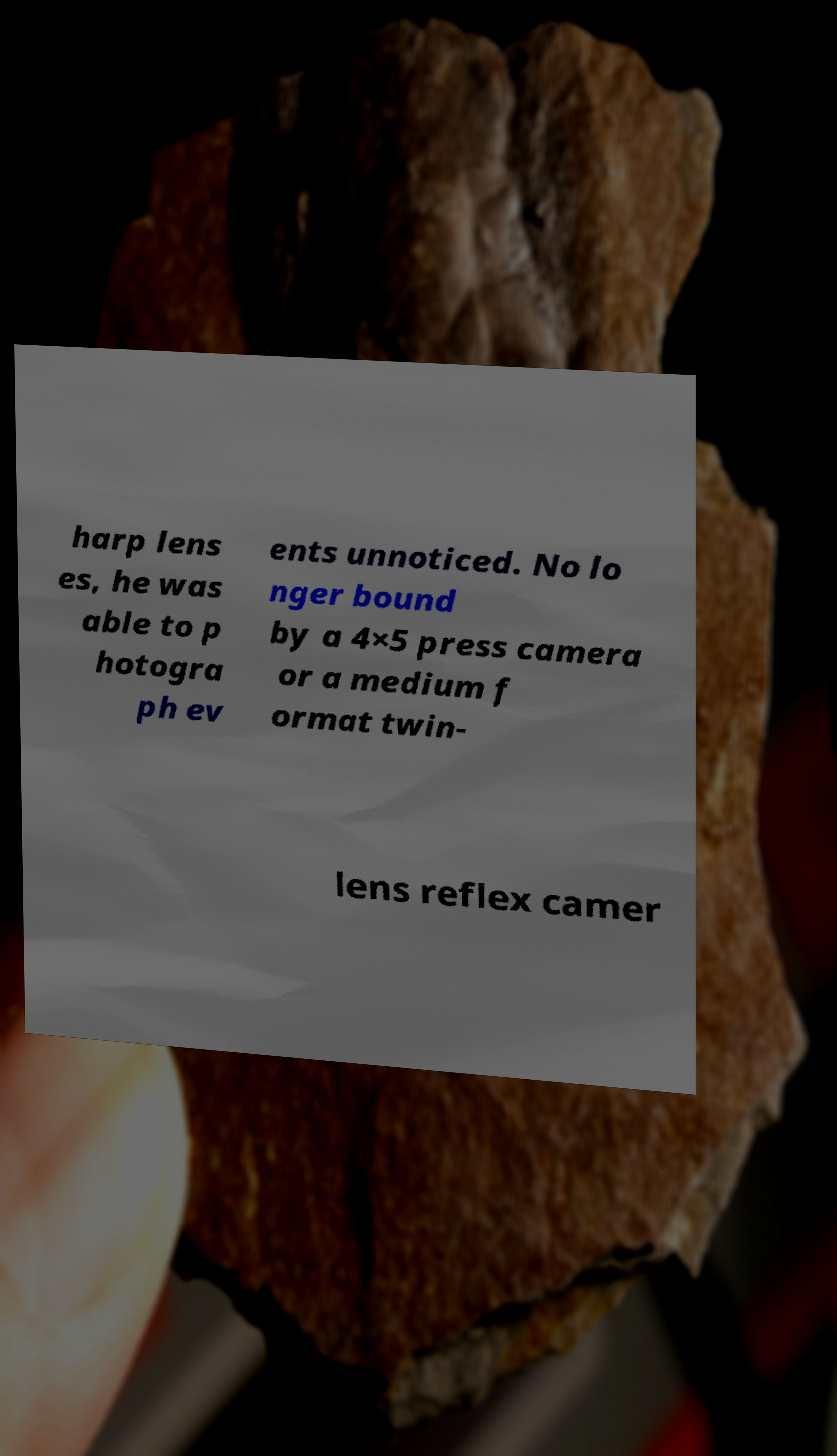Can you accurately transcribe the text from the provided image for me? harp lens es, he was able to p hotogra ph ev ents unnoticed. No lo nger bound by a 4×5 press camera or a medium f ormat twin- lens reflex camer 